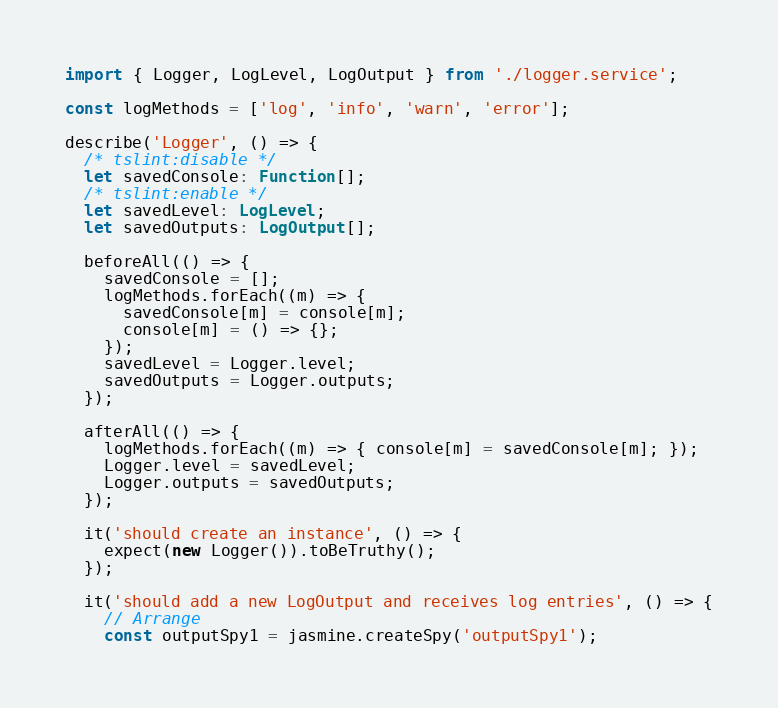<code> <loc_0><loc_0><loc_500><loc_500><_TypeScript_>import { Logger, LogLevel, LogOutput } from './logger.service';

const logMethods = ['log', 'info', 'warn', 'error'];

describe('Logger', () => {
  /* tslint:disable */ 
  let savedConsole: Function[];
  /* tslint:enable */
  let savedLevel: LogLevel;
  let savedOutputs: LogOutput[];

  beforeAll(() => {
    savedConsole = [];
    logMethods.forEach((m) => {
      savedConsole[m] = console[m];
      console[m] = () => {};
    });
    savedLevel = Logger.level;
    savedOutputs = Logger.outputs;
  });

  afterAll(() => {
    logMethods.forEach((m) => { console[m] = savedConsole[m]; });
    Logger.level = savedLevel;
    Logger.outputs = savedOutputs;
  });

  it('should create an instance', () => {
    expect(new Logger()).toBeTruthy();
  });

  it('should add a new LogOutput and receives log entries', () => {
    // Arrange
    const outputSpy1 = jasmine.createSpy('outputSpy1');</code> 